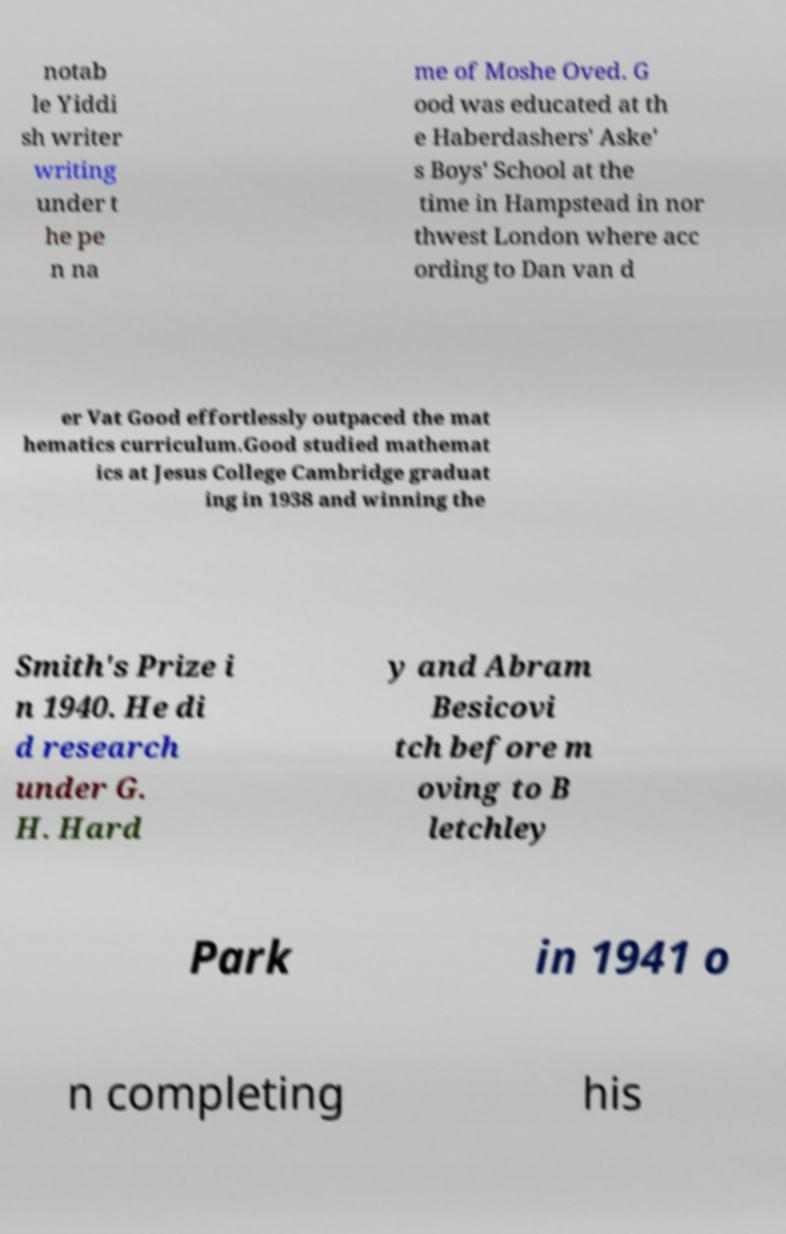Can you read and provide the text displayed in the image?This photo seems to have some interesting text. Can you extract and type it out for me? notab le Yiddi sh writer writing under t he pe n na me of Moshe Oved. G ood was educated at th e Haberdashers' Aske' s Boys' School at the time in Hampstead in nor thwest London where acc ording to Dan van d er Vat Good effortlessly outpaced the mat hematics curriculum.Good studied mathemat ics at Jesus College Cambridge graduat ing in 1938 and winning the Smith's Prize i n 1940. He di d research under G. H. Hard y and Abram Besicovi tch before m oving to B letchley Park in 1941 o n completing his 